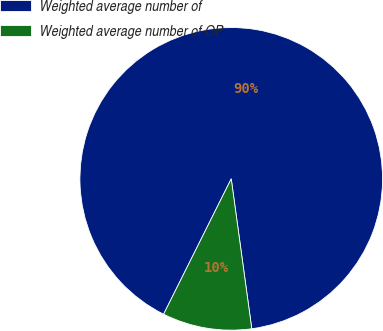<chart> <loc_0><loc_0><loc_500><loc_500><pie_chart><fcel>Weighted average number of<fcel>Weighted average number of OP<nl><fcel>90.46%<fcel>9.54%<nl></chart> 